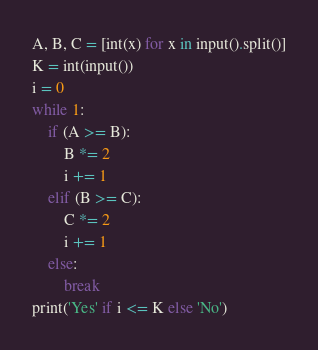<code> <loc_0><loc_0><loc_500><loc_500><_Python_>A, B, C = [int(x) for x in input().split()]
K = int(input())
i = 0
while 1:
    if (A >= B):
        B *= 2
        i += 1
    elif (B >= C):
        C *= 2
        i += 1
    else:
        break
print('Yes' if i <= K else 'No')
</code> 